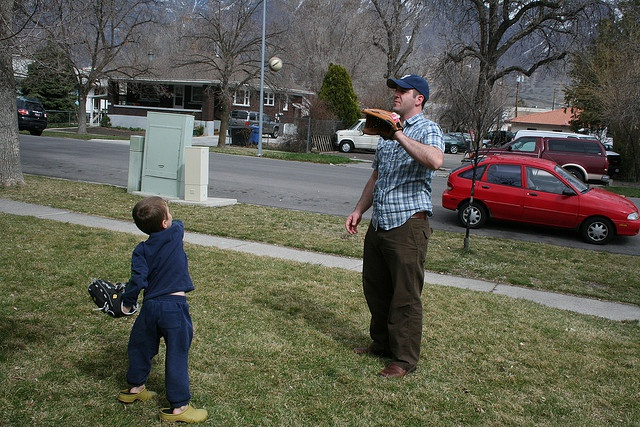Describe the objects in this image and their specific colors. I can see people in gray, black, and darkgray tones, people in gray, black, navy, and olive tones, car in gray, maroon, black, and brown tones, truck in gray, black, maroon, and purple tones, and baseball glove in gray, black, darkgray, and teal tones in this image. 